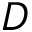Convert formula to latex. <formula><loc_0><loc_0><loc_500><loc_500>D</formula> 